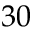<formula> <loc_0><loc_0><loc_500><loc_500>3 0</formula> 